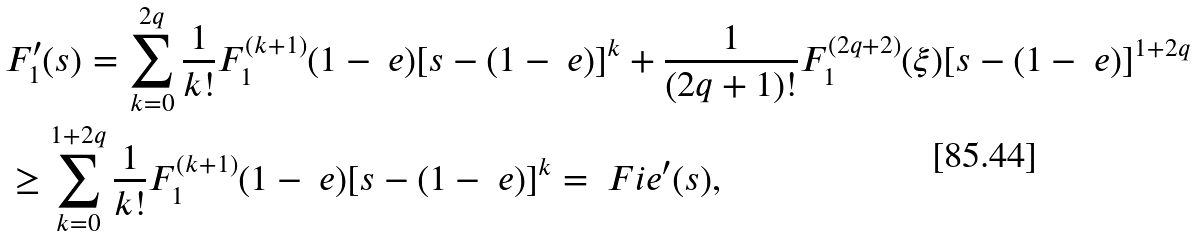<formula> <loc_0><loc_0><loc_500><loc_500>& F _ { 1 } ^ { \prime } ( s ) = \sum _ { k = 0 } ^ { 2 q } \frac { 1 } { k ! } F _ { 1 } ^ { ( k + 1 ) } ( 1 - \ e ) [ s - ( 1 - \ e ) ] ^ { k } + \frac { 1 } { ( 2 q + 1 ) ! } F _ { 1 } ^ { ( 2 q + 2 ) } ( \xi ) [ s - ( 1 - \ e ) ] ^ { 1 + 2 q } \\ & \geq \sum _ { k = 0 } ^ { 1 + 2 q } \frac { 1 } { k ! } F _ { 1 } ^ { ( k + 1 ) } ( 1 - \ e ) [ s - ( 1 - \ e ) ] ^ { k } = \ F i e ^ { \prime } ( s ) ,</formula> 